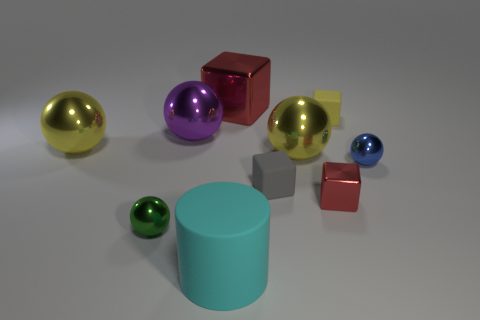Are there any yellow metallic balls in front of the yellow thing that is left of the cube that is on the left side of the tiny gray block?
Ensure brevity in your answer.  Yes. What is the color of the rubber object that is the same size as the yellow block?
Provide a short and direct response. Gray. There is a thing that is in front of the tiny blue thing and behind the small red shiny object; what shape is it?
Offer a terse response. Cube. How big is the red metal cube that is in front of the tiny shiny ball on the right side of the gray cube?
Offer a terse response. Small. How many metallic objects are the same color as the big metal cube?
Your answer should be very brief. 1. How many other things are the same size as the yellow rubber cube?
Your answer should be compact. 4. What is the size of the ball that is both left of the purple ball and behind the small gray object?
Ensure brevity in your answer.  Large. What number of yellow matte objects are the same shape as the purple shiny thing?
Ensure brevity in your answer.  0. What material is the tiny gray cube?
Make the answer very short. Rubber. Do the green thing and the blue metal thing have the same shape?
Ensure brevity in your answer.  Yes. 